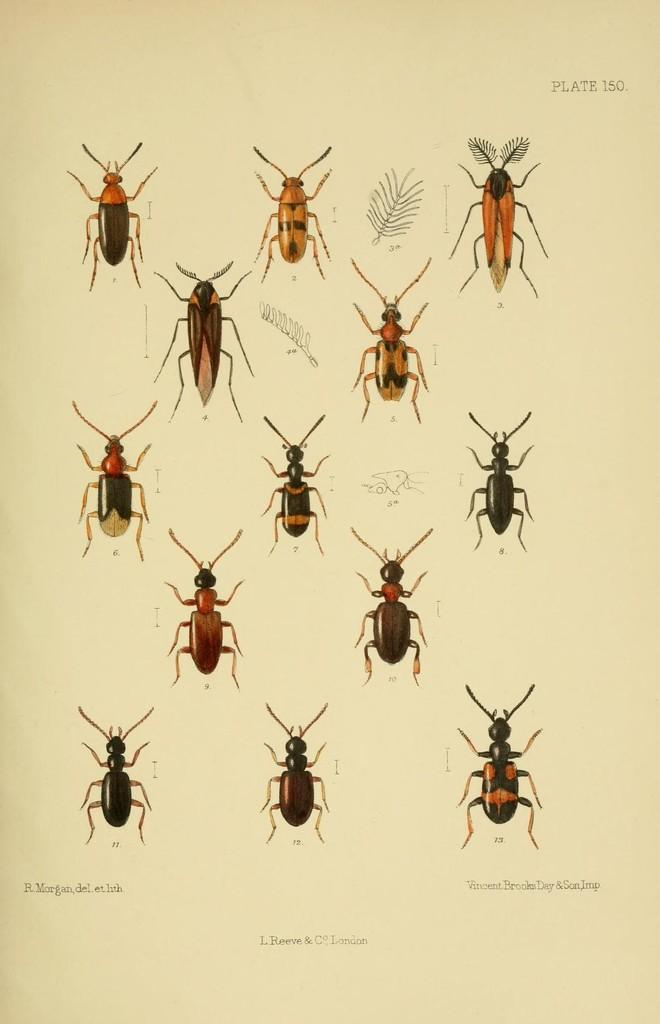What is present in the image related to written material? There is a paper in the image. What type of images are on the paper? The paper contains pictures of insects. Is there any text on the paper? Yes, there is text on the paper. What type of coach is mentioned in the text on the paper? There is no mention of a coach in the text on the paper, as the facts provided do not mention any text related to a coach. 